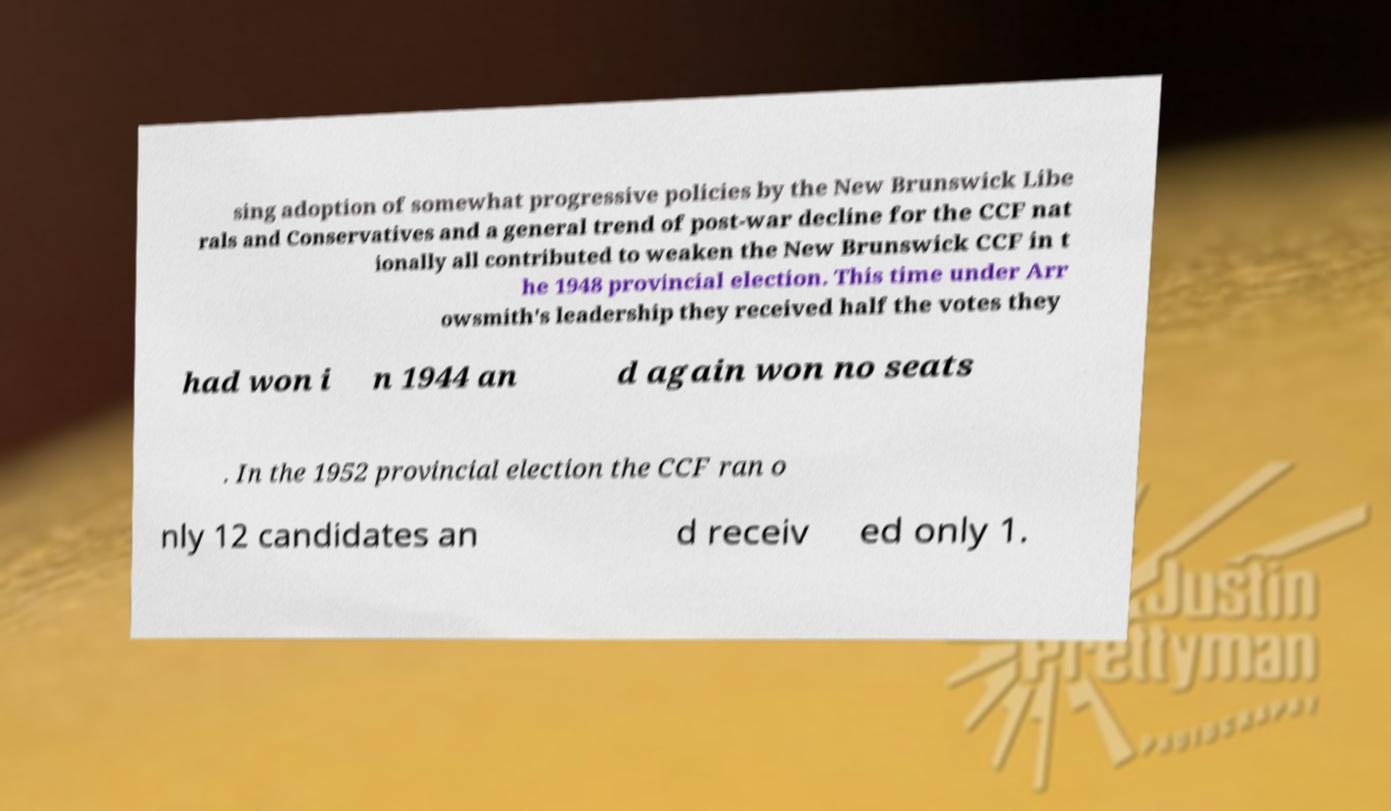Can you read and provide the text displayed in the image?This photo seems to have some interesting text. Can you extract and type it out for me? sing adoption of somewhat progressive policies by the New Brunswick Libe rals and Conservatives and a general trend of post-war decline for the CCF nat ionally all contributed to weaken the New Brunswick CCF in t he 1948 provincial election. This time under Arr owsmith's leadership they received half the votes they had won i n 1944 an d again won no seats . In the 1952 provincial election the CCF ran o nly 12 candidates an d receiv ed only 1. 